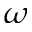<formula> <loc_0><loc_0><loc_500><loc_500>\omega</formula> 